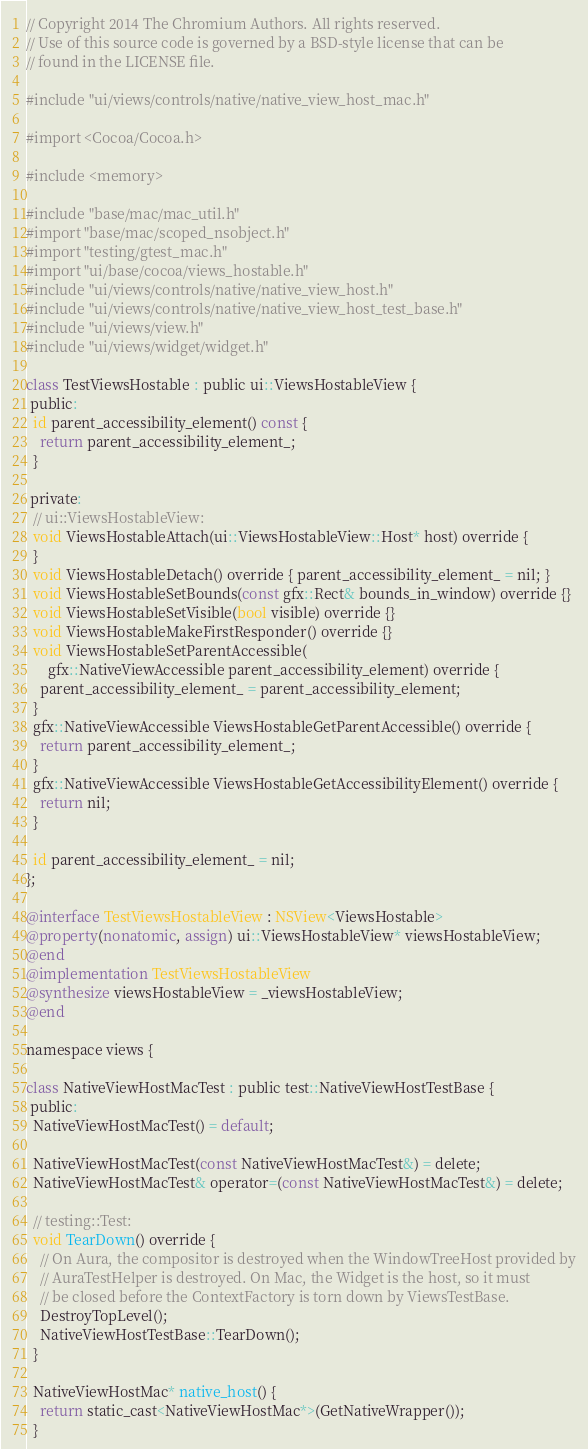Convert code to text. <code><loc_0><loc_0><loc_500><loc_500><_ObjectiveC_>// Copyright 2014 The Chromium Authors. All rights reserved.
// Use of this source code is governed by a BSD-style license that can be
// found in the LICENSE file.

#include "ui/views/controls/native/native_view_host_mac.h"

#import <Cocoa/Cocoa.h>

#include <memory>

#include "base/mac/mac_util.h"
#import "base/mac/scoped_nsobject.h"
#import "testing/gtest_mac.h"
#import "ui/base/cocoa/views_hostable.h"
#include "ui/views/controls/native/native_view_host.h"
#include "ui/views/controls/native/native_view_host_test_base.h"
#include "ui/views/view.h"
#include "ui/views/widget/widget.h"

class TestViewsHostable : public ui::ViewsHostableView {
 public:
  id parent_accessibility_element() const {
    return parent_accessibility_element_;
  }

 private:
  // ui::ViewsHostableView:
  void ViewsHostableAttach(ui::ViewsHostableView::Host* host) override {
  }
  void ViewsHostableDetach() override { parent_accessibility_element_ = nil; }
  void ViewsHostableSetBounds(const gfx::Rect& bounds_in_window) override {}
  void ViewsHostableSetVisible(bool visible) override {}
  void ViewsHostableMakeFirstResponder() override {}
  void ViewsHostableSetParentAccessible(
      gfx::NativeViewAccessible parent_accessibility_element) override {
    parent_accessibility_element_ = parent_accessibility_element;
  }
  gfx::NativeViewAccessible ViewsHostableGetParentAccessible() override {
    return parent_accessibility_element_;
  }
  gfx::NativeViewAccessible ViewsHostableGetAccessibilityElement() override {
    return nil;
  }

  id parent_accessibility_element_ = nil;
};

@interface TestViewsHostableView : NSView<ViewsHostable>
@property(nonatomic, assign) ui::ViewsHostableView* viewsHostableView;
@end
@implementation TestViewsHostableView
@synthesize viewsHostableView = _viewsHostableView;
@end

namespace views {

class NativeViewHostMacTest : public test::NativeViewHostTestBase {
 public:
  NativeViewHostMacTest() = default;

  NativeViewHostMacTest(const NativeViewHostMacTest&) = delete;
  NativeViewHostMacTest& operator=(const NativeViewHostMacTest&) = delete;

  // testing::Test:
  void TearDown() override {
    // On Aura, the compositor is destroyed when the WindowTreeHost provided by
    // AuraTestHelper is destroyed. On Mac, the Widget is the host, so it must
    // be closed before the ContextFactory is torn down by ViewsTestBase.
    DestroyTopLevel();
    NativeViewHostTestBase::TearDown();
  }

  NativeViewHostMac* native_host() {
    return static_cast<NativeViewHostMac*>(GetNativeWrapper());
  }
</code> 